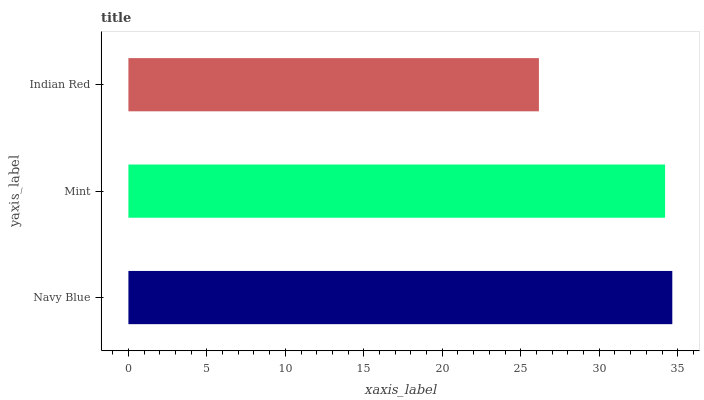Is Indian Red the minimum?
Answer yes or no. Yes. Is Navy Blue the maximum?
Answer yes or no. Yes. Is Mint the minimum?
Answer yes or no. No. Is Mint the maximum?
Answer yes or no. No. Is Navy Blue greater than Mint?
Answer yes or no. Yes. Is Mint less than Navy Blue?
Answer yes or no. Yes. Is Mint greater than Navy Blue?
Answer yes or no. No. Is Navy Blue less than Mint?
Answer yes or no. No. Is Mint the high median?
Answer yes or no. Yes. Is Mint the low median?
Answer yes or no. Yes. Is Indian Red the high median?
Answer yes or no. No. Is Navy Blue the low median?
Answer yes or no. No. 